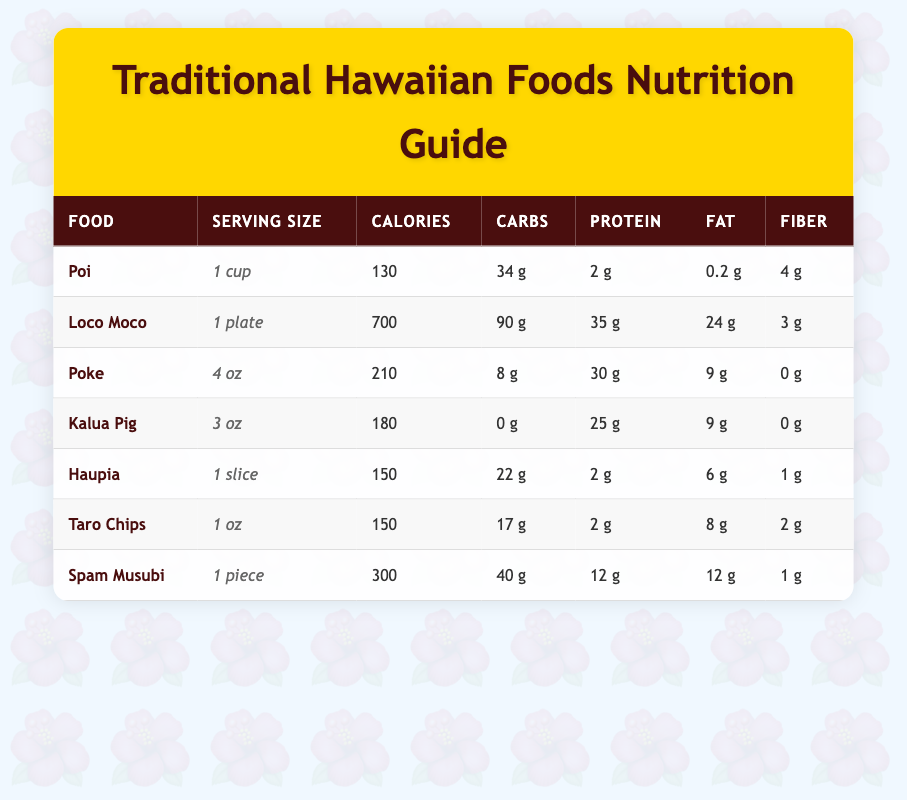What is the serving size of Spam Musubi? According to the table, the serving size for Spam Musubi is listed as "1 piece."
Answer: 1 piece How many calories does a plate of Loco Moco contain? The table indicates that a plate of Loco Moco contains 700 calories.
Answer: 700 Which food has the highest protein content? Looking at the protein values in the table, Loco Moco has 35 g of protein, which is the highest among all listed foods.
Answer: Loco Moco What is the total carbohydrate content of Poi and Haupia combined? The carbohydrates in Poi (34 g) and Haupia (22 g) can be summed up: 34 g + 22 g = 56 g.
Answer: 56 g Is Kalua Pig high in carbohydrates? The table shows that Kalua Pig has 0 g of carbohydrates, indicating it is not high in this nutrient.
Answer: No What is the difference in calorie content between Taro Chips and Haupia? Taro Chips have 150 calories, and Haupia has 150 calories as well. The difference is calculated as 150 - 150 = 0.
Answer: 0 If you were to consume one serving of each food, what would be the total calorie intake? The total calorie intake can be calculated by adding together all the calorie values: 130 (Poi) + 700 (Loco Moco) + 210 (Poke) + 180 (Kalua Pig) + 150 (Haupia) + 150 (Taro Chips) + 300 (Spam Musubi) = 1820 calories.
Answer: 1820 Does Haupia contain more fiber than Poke? Haupia contains 1 g of fiber while Poke has 0 g. Since 1 g is greater than 0 g, this statement is true.
Answer: Yes What food has the lowest fat content? The table shows that Poi has the lowest fat content at 0.2 g.
Answer: Poi 